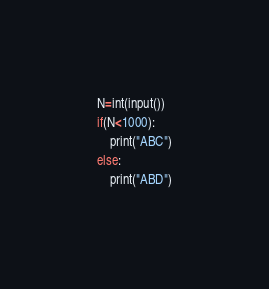<code> <loc_0><loc_0><loc_500><loc_500><_Python_>N=int(input())
if(N<1000):
    print("ABC")
else:
    print("ABD")</code> 